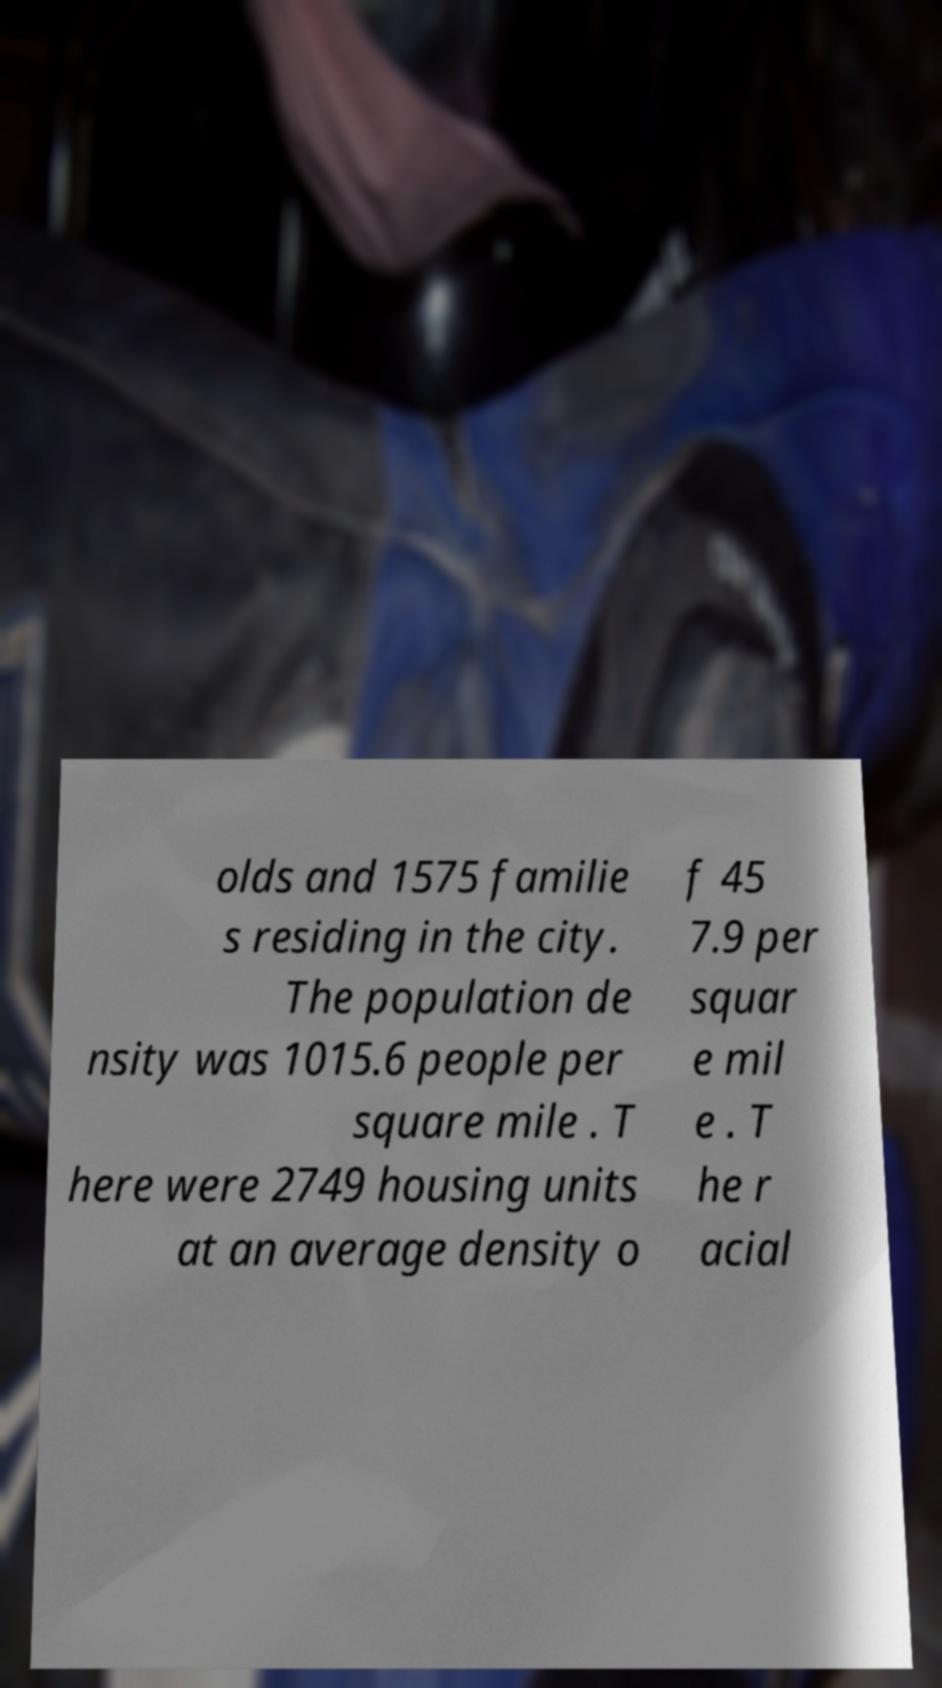Please identify and transcribe the text found in this image. olds and 1575 familie s residing in the city. The population de nsity was 1015.6 people per square mile . T here were 2749 housing units at an average density o f 45 7.9 per squar e mil e . T he r acial 